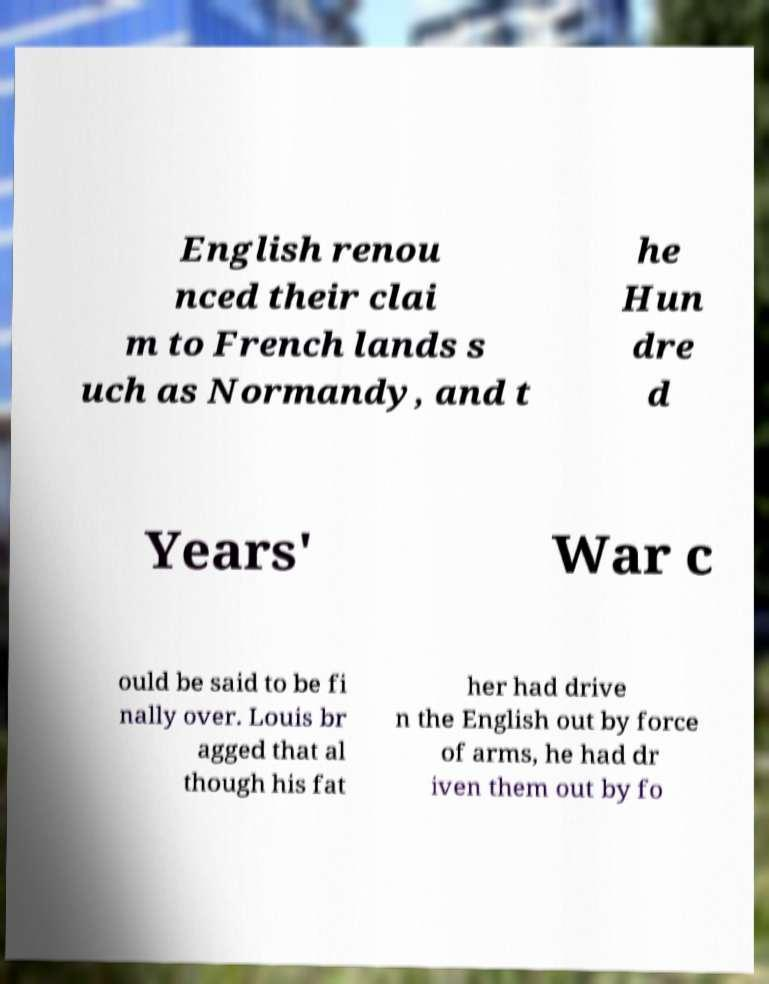For documentation purposes, I need the text within this image transcribed. Could you provide that? English renou nced their clai m to French lands s uch as Normandy, and t he Hun dre d Years' War c ould be said to be fi nally over. Louis br agged that al though his fat her had drive n the English out by force of arms, he had dr iven them out by fo 